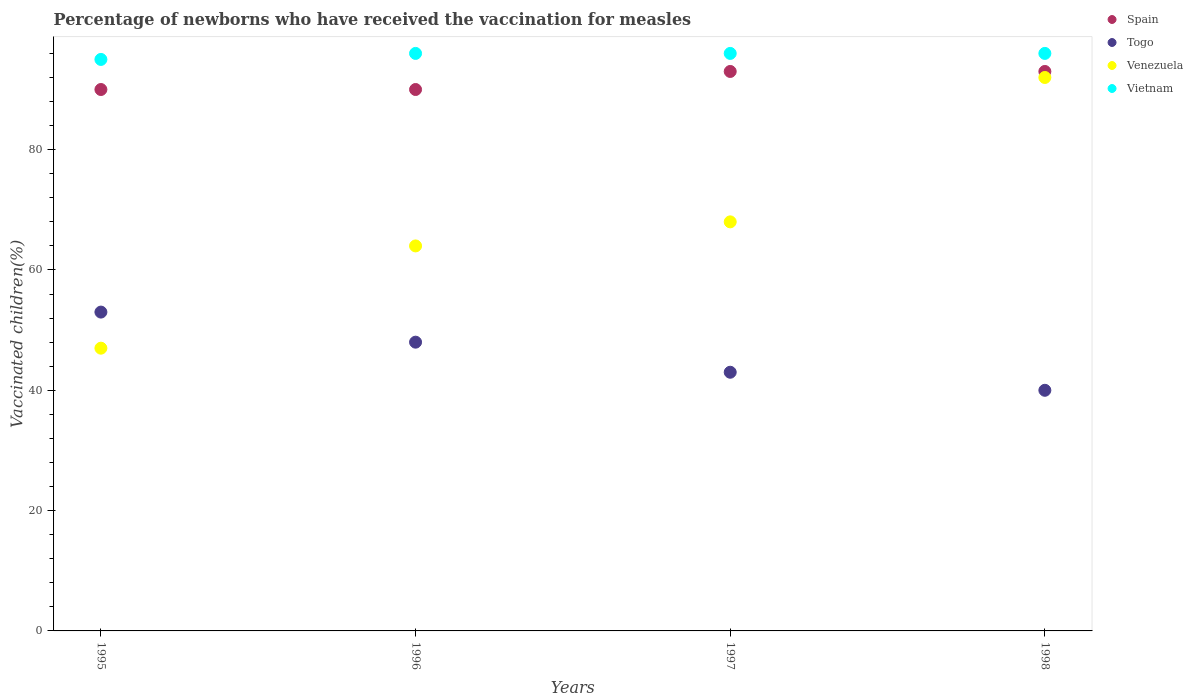How many different coloured dotlines are there?
Offer a very short reply. 4. Is the number of dotlines equal to the number of legend labels?
Ensure brevity in your answer.  Yes. What is the percentage of vaccinated children in Venezuela in 1998?
Your answer should be very brief. 92. Across all years, what is the maximum percentage of vaccinated children in Vietnam?
Provide a succinct answer. 96. Across all years, what is the minimum percentage of vaccinated children in Venezuela?
Provide a succinct answer. 47. In which year was the percentage of vaccinated children in Venezuela maximum?
Your answer should be compact. 1998. In which year was the percentage of vaccinated children in Vietnam minimum?
Your response must be concise. 1995. What is the total percentage of vaccinated children in Venezuela in the graph?
Your answer should be very brief. 271. What is the difference between the percentage of vaccinated children in Venezuela in 1995 and that in 1998?
Your answer should be very brief. -45. What is the difference between the percentage of vaccinated children in Togo in 1997 and the percentage of vaccinated children in Venezuela in 1996?
Your response must be concise. -21. In the year 1998, what is the difference between the percentage of vaccinated children in Venezuela and percentage of vaccinated children in Vietnam?
Ensure brevity in your answer.  -4. In how many years, is the percentage of vaccinated children in Venezuela greater than 12 %?
Your response must be concise. 4. What is the ratio of the percentage of vaccinated children in Venezuela in 1995 to that in 1998?
Keep it short and to the point. 0.51. Is the percentage of vaccinated children in Spain in 1995 less than that in 1998?
Ensure brevity in your answer.  Yes. Is the difference between the percentage of vaccinated children in Venezuela in 1995 and 1997 greater than the difference between the percentage of vaccinated children in Vietnam in 1995 and 1997?
Give a very brief answer. No. In how many years, is the percentage of vaccinated children in Spain greater than the average percentage of vaccinated children in Spain taken over all years?
Give a very brief answer. 2. Does the percentage of vaccinated children in Venezuela monotonically increase over the years?
Make the answer very short. Yes. Is the percentage of vaccinated children in Spain strictly greater than the percentage of vaccinated children in Vietnam over the years?
Provide a succinct answer. No. Is the percentage of vaccinated children in Vietnam strictly less than the percentage of vaccinated children in Spain over the years?
Make the answer very short. No. How many dotlines are there?
Make the answer very short. 4. How many years are there in the graph?
Keep it short and to the point. 4. What is the difference between two consecutive major ticks on the Y-axis?
Your response must be concise. 20. Does the graph contain any zero values?
Offer a very short reply. No. Does the graph contain grids?
Provide a succinct answer. No. How many legend labels are there?
Your response must be concise. 4. What is the title of the graph?
Provide a short and direct response. Percentage of newborns who have received the vaccination for measles. Does "Vanuatu" appear as one of the legend labels in the graph?
Offer a terse response. No. What is the label or title of the Y-axis?
Offer a terse response. Vaccinated children(%). What is the Vaccinated children(%) of Togo in 1995?
Provide a succinct answer. 53. What is the Vaccinated children(%) of Venezuela in 1995?
Your response must be concise. 47. What is the Vaccinated children(%) of Vietnam in 1995?
Make the answer very short. 95. What is the Vaccinated children(%) of Togo in 1996?
Make the answer very short. 48. What is the Vaccinated children(%) of Vietnam in 1996?
Offer a terse response. 96. What is the Vaccinated children(%) of Spain in 1997?
Give a very brief answer. 93. What is the Vaccinated children(%) in Venezuela in 1997?
Your answer should be compact. 68. What is the Vaccinated children(%) in Vietnam in 1997?
Offer a very short reply. 96. What is the Vaccinated children(%) in Spain in 1998?
Offer a terse response. 93. What is the Vaccinated children(%) in Togo in 1998?
Your answer should be very brief. 40. What is the Vaccinated children(%) of Venezuela in 1998?
Provide a succinct answer. 92. What is the Vaccinated children(%) of Vietnam in 1998?
Your response must be concise. 96. Across all years, what is the maximum Vaccinated children(%) in Spain?
Give a very brief answer. 93. Across all years, what is the maximum Vaccinated children(%) in Togo?
Offer a very short reply. 53. Across all years, what is the maximum Vaccinated children(%) of Venezuela?
Your answer should be very brief. 92. Across all years, what is the maximum Vaccinated children(%) of Vietnam?
Your response must be concise. 96. Across all years, what is the minimum Vaccinated children(%) in Spain?
Ensure brevity in your answer.  90. Across all years, what is the minimum Vaccinated children(%) of Vietnam?
Your answer should be compact. 95. What is the total Vaccinated children(%) of Spain in the graph?
Your response must be concise. 366. What is the total Vaccinated children(%) of Togo in the graph?
Offer a terse response. 184. What is the total Vaccinated children(%) in Venezuela in the graph?
Offer a very short reply. 271. What is the total Vaccinated children(%) in Vietnam in the graph?
Your answer should be very brief. 383. What is the difference between the Vaccinated children(%) in Spain in 1995 and that in 1996?
Offer a terse response. 0. What is the difference between the Vaccinated children(%) in Vietnam in 1995 and that in 1996?
Your response must be concise. -1. What is the difference between the Vaccinated children(%) in Spain in 1995 and that in 1997?
Your answer should be very brief. -3. What is the difference between the Vaccinated children(%) in Togo in 1995 and that in 1997?
Your response must be concise. 10. What is the difference between the Vaccinated children(%) in Vietnam in 1995 and that in 1997?
Provide a short and direct response. -1. What is the difference between the Vaccinated children(%) of Togo in 1995 and that in 1998?
Offer a terse response. 13. What is the difference between the Vaccinated children(%) in Venezuela in 1995 and that in 1998?
Provide a succinct answer. -45. What is the difference between the Vaccinated children(%) of Vietnam in 1995 and that in 1998?
Provide a short and direct response. -1. What is the difference between the Vaccinated children(%) in Spain in 1996 and that in 1997?
Give a very brief answer. -3. What is the difference between the Vaccinated children(%) of Togo in 1996 and that in 1997?
Keep it short and to the point. 5. What is the difference between the Vaccinated children(%) in Venezuela in 1996 and that in 1997?
Ensure brevity in your answer.  -4. What is the difference between the Vaccinated children(%) in Vietnam in 1996 and that in 1997?
Give a very brief answer. 0. What is the difference between the Vaccinated children(%) of Vietnam in 1996 and that in 1998?
Ensure brevity in your answer.  0. What is the difference between the Vaccinated children(%) of Spain in 1997 and that in 1998?
Your answer should be very brief. 0. What is the difference between the Vaccinated children(%) in Togo in 1997 and that in 1998?
Provide a short and direct response. 3. What is the difference between the Vaccinated children(%) in Vietnam in 1997 and that in 1998?
Make the answer very short. 0. What is the difference between the Vaccinated children(%) in Spain in 1995 and the Vaccinated children(%) in Venezuela in 1996?
Provide a short and direct response. 26. What is the difference between the Vaccinated children(%) in Spain in 1995 and the Vaccinated children(%) in Vietnam in 1996?
Your answer should be compact. -6. What is the difference between the Vaccinated children(%) in Togo in 1995 and the Vaccinated children(%) in Vietnam in 1996?
Give a very brief answer. -43. What is the difference between the Vaccinated children(%) in Venezuela in 1995 and the Vaccinated children(%) in Vietnam in 1996?
Your response must be concise. -49. What is the difference between the Vaccinated children(%) of Spain in 1995 and the Vaccinated children(%) of Togo in 1997?
Provide a succinct answer. 47. What is the difference between the Vaccinated children(%) in Spain in 1995 and the Vaccinated children(%) in Venezuela in 1997?
Your answer should be very brief. 22. What is the difference between the Vaccinated children(%) in Spain in 1995 and the Vaccinated children(%) in Vietnam in 1997?
Provide a succinct answer. -6. What is the difference between the Vaccinated children(%) in Togo in 1995 and the Vaccinated children(%) in Venezuela in 1997?
Your answer should be very brief. -15. What is the difference between the Vaccinated children(%) in Togo in 1995 and the Vaccinated children(%) in Vietnam in 1997?
Keep it short and to the point. -43. What is the difference between the Vaccinated children(%) in Venezuela in 1995 and the Vaccinated children(%) in Vietnam in 1997?
Your response must be concise. -49. What is the difference between the Vaccinated children(%) in Spain in 1995 and the Vaccinated children(%) in Venezuela in 1998?
Your answer should be compact. -2. What is the difference between the Vaccinated children(%) of Togo in 1995 and the Vaccinated children(%) of Venezuela in 1998?
Provide a short and direct response. -39. What is the difference between the Vaccinated children(%) of Togo in 1995 and the Vaccinated children(%) of Vietnam in 1998?
Ensure brevity in your answer.  -43. What is the difference between the Vaccinated children(%) of Venezuela in 1995 and the Vaccinated children(%) of Vietnam in 1998?
Your answer should be compact. -49. What is the difference between the Vaccinated children(%) of Spain in 1996 and the Vaccinated children(%) of Togo in 1997?
Keep it short and to the point. 47. What is the difference between the Vaccinated children(%) in Spain in 1996 and the Vaccinated children(%) in Venezuela in 1997?
Your response must be concise. 22. What is the difference between the Vaccinated children(%) of Togo in 1996 and the Vaccinated children(%) of Venezuela in 1997?
Give a very brief answer. -20. What is the difference between the Vaccinated children(%) in Togo in 1996 and the Vaccinated children(%) in Vietnam in 1997?
Offer a terse response. -48. What is the difference between the Vaccinated children(%) of Venezuela in 1996 and the Vaccinated children(%) of Vietnam in 1997?
Your answer should be very brief. -32. What is the difference between the Vaccinated children(%) of Spain in 1996 and the Vaccinated children(%) of Venezuela in 1998?
Keep it short and to the point. -2. What is the difference between the Vaccinated children(%) of Togo in 1996 and the Vaccinated children(%) of Venezuela in 1998?
Give a very brief answer. -44. What is the difference between the Vaccinated children(%) of Togo in 1996 and the Vaccinated children(%) of Vietnam in 1998?
Your answer should be very brief. -48. What is the difference between the Vaccinated children(%) in Venezuela in 1996 and the Vaccinated children(%) in Vietnam in 1998?
Your response must be concise. -32. What is the difference between the Vaccinated children(%) in Togo in 1997 and the Vaccinated children(%) in Venezuela in 1998?
Offer a very short reply. -49. What is the difference between the Vaccinated children(%) in Togo in 1997 and the Vaccinated children(%) in Vietnam in 1998?
Offer a very short reply. -53. What is the difference between the Vaccinated children(%) in Venezuela in 1997 and the Vaccinated children(%) in Vietnam in 1998?
Provide a succinct answer. -28. What is the average Vaccinated children(%) of Spain per year?
Offer a terse response. 91.5. What is the average Vaccinated children(%) of Venezuela per year?
Your response must be concise. 67.75. What is the average Vaccinated children(%) of Vietnam per year?
Offer a terse response. 95.75. In the year 1995, what is the difference between the Vaccinated children(%) of Spain and Vaccinated children(%) of Venezuela?
Offer a terse response. 43. In the year 1995, what is the difference between the Vaccinated children(%) in Spain and Vaccinated children(%) in Vietnam?
Give a very brief answer. -5. In the year 1995, what is the difference between the Vaccinated children(%) of Togo and Vaccinated children(%) of Vietnam?
Make the answer very short. -42. In the year 1995, what is the difference between the Vaccinated children(%) of Venezuela and Vaccinated children(%) of Vietnam?
Your answer should be compact. -48. In the year 1996, what is the difference between the Vaccinated children(%) in Spain and Vaccinated children(%) in Togo?
Provide a succinct answer. 42. In the year 1996, what is the difference between the Vaccinated children(%) in Spain and Vaccinated children(%) in Vietnam?
Keep it short and to the point. -6. In the year 1996, what is the difference between the Vaccinated children(%) in Togo and Vaccinated children(%) in Vietnam?
Your answer should be compact. -48. In the year 1996, what is the difference between the Vaccinated children(%) in Venezuela and Vaccinated children(%) in Vietnam?
Your response must be concise. -32. In the year 1997, what is the difference between the Vaccinated children(%) in Spain and Vaccinated children(%) in Togo?
Give a very brief answer. 50. In the year 1997, what is the difference between the Vaccinated children(%) in Togo and Vaccinated children(%) in Venezuela?
Ensure brevity in your answer.  -25. In the year 1997, what is the difference between the Vaccinated children(%) in Togo and Vaccinated children(%) in Vietnam?
Give a very brief answer. -53. In the year 1997, what is the difference between the Vaccinated children(%) of Venezuela and Vaccinated children(%) of Vietnam?
Offer a terse response. -28. In the year 1998, what is the difference between the Vaccinated children(%) in Togo and Vaccinated children(%) in Venezuela?
Provide a short and direct response. -52. In the year 1998, what is the difference between the Vaccinated children(%) in Togo and Vaccinated children(%) in Vietnam?
Provide a succinct answer. -56. What is the ratio of the Vaccinated children(%) in Spain in 1995 to that in 1996?
Your response must be concise. 1. What is the ratio of the Vaccinated children(%) of Togo in 1995 to that in 1996?
Your response must be concise. 1.1. What is the ratio of the Vaccinated children(%) in Venezuela in 1995 to that in 1996?
Keep it short and to the point. 0.73. What is the ratio of the Vaccinated children(%) in Vietnam in 1995 to that in 1996?
Your answer should be compact. 0.99. What is the ratio of the Vaccinated children(%) in Togo in 1995 to that in 1997?
Your answer should be very brief. 1.23. What is the ratio of the Vaccinated children(%) of Venezuela in 1995 to that in 1997?
Offer a terse response. 0.69. What is the ratio of the Vaccinated children(%) of Vietnam in 1995 to that in 1997?
Your answer should be very brief. 0.99. What is the ratio of the Vaccinated children(%) in Spain in 1995 to that in 1998?
Give a very brief answer. 0.97. What is the ratio of the Vaccinated children(%) in Togo in 1995 to that in 1998?
Your answer should be compact. 1.32. What is the ratio of the Vaccinated children(%) in Venezuela in 1995 to that in 1998?
Keep it short and to the point. 0.51. What is the ratio of the Vaccinated children(%) in Vietnam in 1995 to that in 1998?
Ensure brevity in your answer.  0.99. What is the ratio of the Vaccinated children(%) in Togo in 1996 to that in 1997?
Your answer should be compact. 1.12. What is the ratio of the Vaccinated children(%) in Venezuela in 1996 to that in 1997?
Make the answer very short. 0.94. What is the ratio of the Vaccinated children(%) in Vietnam in 1996 to that in 1997?
Provide a succinct answer. 1. What is the ratio of the Vaccinated children(%) of Venezuela in 1996 to that in 1998?
Make the answer very short. 0.7. What is the ratio of the Vaccinated children(%) in Spain in 1997 to that in 1998?
Your answer should be compact. 1. What is the ratio of the Vaccinated children(%) in Togo in 1997 to that in 1998?
Provide a succinct answer. 1.07. What is the ratio of the Vaccinated children(%) of Venezuela in 1997 to that in 1998?
Provide a succinct answer. 0.74. What is the difference between the highest and the second highest Vaccinated children(%) of Spain?
Ensure brevity in your answer.  0. What is the difference between the highest and the second highest Vaccinated children(%) of Togo?
Your response must be concise. 5. What is the difference between the highest and the lowest Vaccinated children(%) in Spain?
Offer a terse response. 3. What is the difference between the highest and the lowest Vaccinated children(%) in Venezuela?
Offer a terse response. 45. What is the difference between the highest and the lowest Vaccinated children(%) in Vietnam?
Offer a very short reply. 1. 